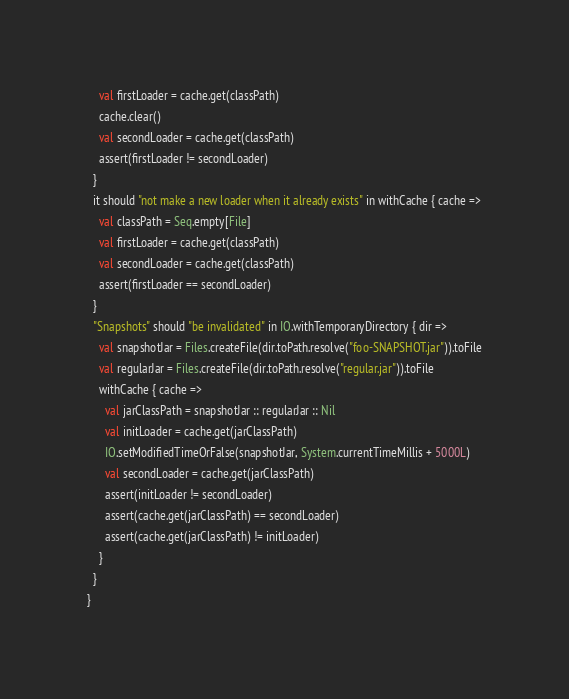Convert code to text. <code><loc_0><loc_0><loc_500><loc_500><_Scala_>    val firstLoader = cache.get(classPath)
    cache.clear()
    val secondLoader = cache.get(classPath)
    assert(firstLoader != secondLoader)
  }
  it should "not make a new loader when it already exists" in withCache { cache =>
    val classPath = Seq.empty[File]
    val firstLoader = cache.get(classPath)
    val secondLoader = cache.get(classPath)
    assert(firstLoader == secondLoader)
  }
  "Snapshots" should "be invalidated" in IO.withTemporaryDirectory { dir =>
    val snapshotJar = Files.createFile(dir.toPath.resolve("foo-SNAPSHOT.jar")).toFile
    val regularJar = Files.createFile(dir.toPath.resolve("regular.jar")).toFile
    withCache { cache =>
      val jarClassPath = snapshotJar :: regularJar :: Nil
      val initLoader = cache.get(jarClassPath)
      IO.setModifiedTimeOrFalse(snapshotJar, System.currentTimeMillis + 5000L)
      val secondLoader = cache.get(jarClassPath)
      assert(initLoader != secondLoader)
      assert(cache.get(jarClassPath) == secondLoader)
      assert(cache.get(jarClassPath) != initLoader)
    }
  }
}
</code> 